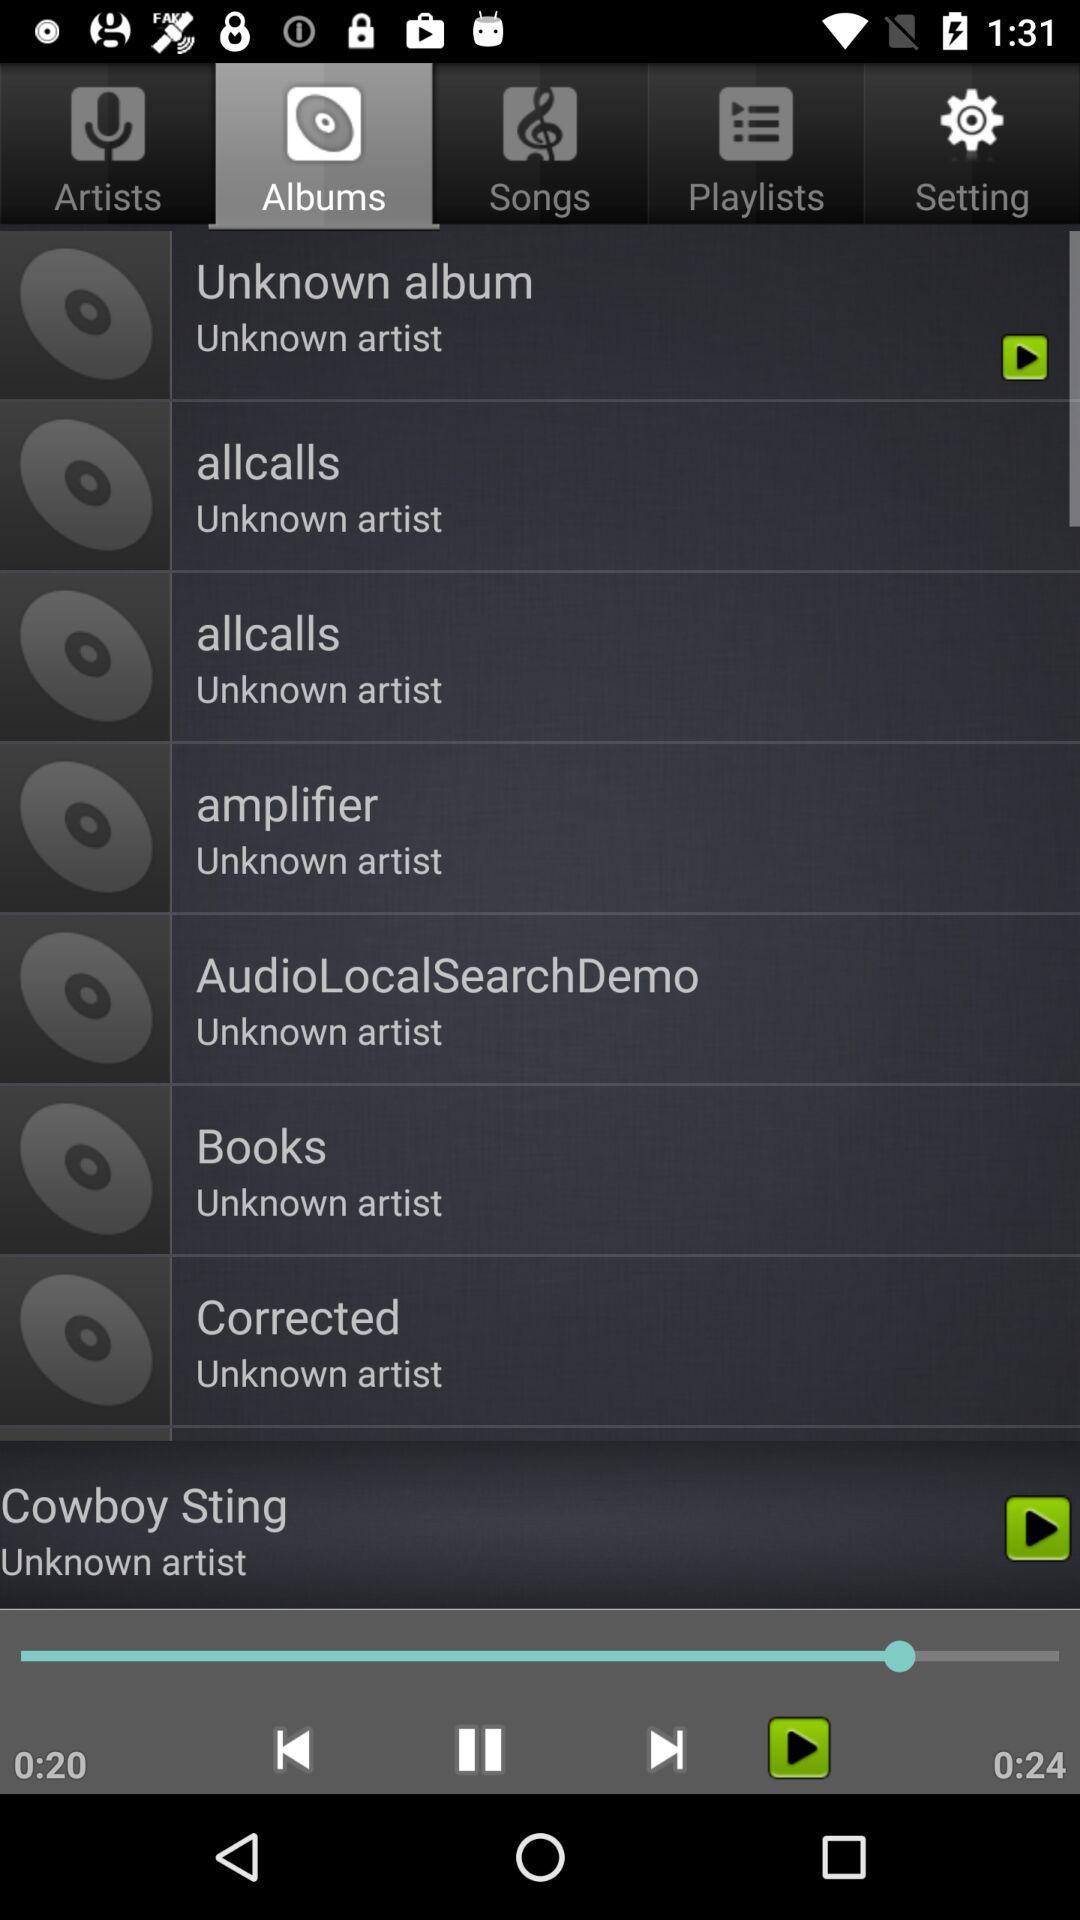What is the duration of the song? The duration of the song is 24 seconds. 